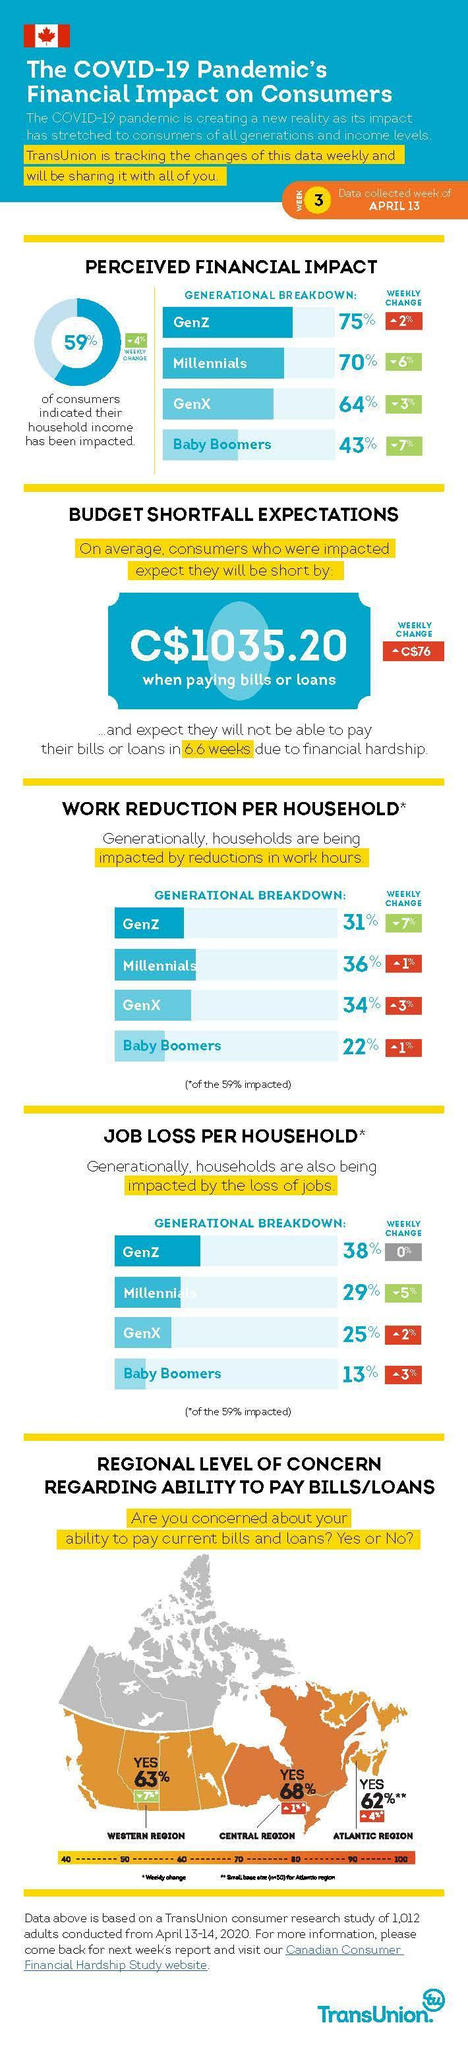Which generation has been affected the most due to job loss?
Answer the question with a short phrase. GenZ From which generation did the lowest percentage of people report financial impact? Baby Boomers People from which generation form the second highest % of being affected by reduced work hours? GenX People in which area are most concerned about bills and loan payments? central region Consumers of which generation are least affected by loss of jobs? Baby Boomers Consumers of which generation are most affected by reductions in work hours? millennials 